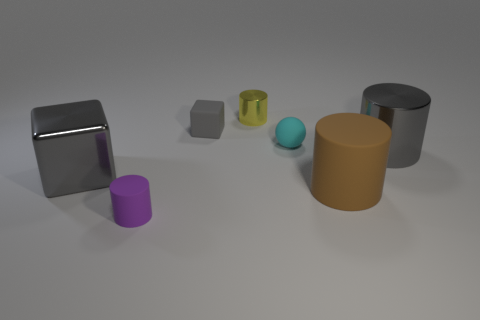How many gray cubes must be subtracted to get 1 gray cubes? 1 Subtract 2 cylinders. How many cylinders are left? 2 Subtract all big gray metal cylinders. How many cylinders are left? 3 Subtract all red cylinders. Subtract all cyan blocks. How many cylinders are left? 4 Add 2 green things. How many objects exist? 9 Subtract all cylinders. How many objects are left? 3 Subtract 1 cyan spheres. How many objects are left? 6 Subtract all large metallic spheres. Subtract all tiny metal objects. How many objects are left? 6 Add 6 tiny rubber things. How many tiny rubber things are left? 9 Add 7 purple cylinders. How many purple cylinders exist? 8 